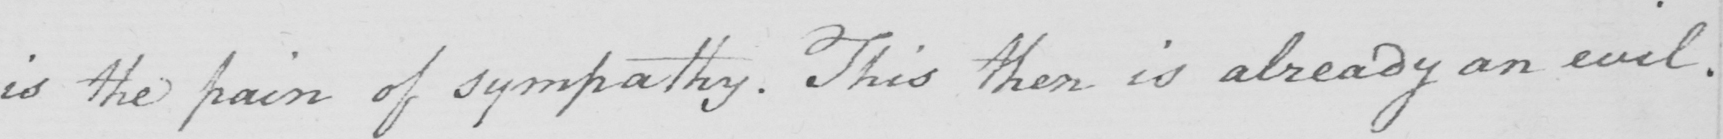Can you tell me what this handwritten text says? is the pain of sympathy . This then is aleady an evil . 